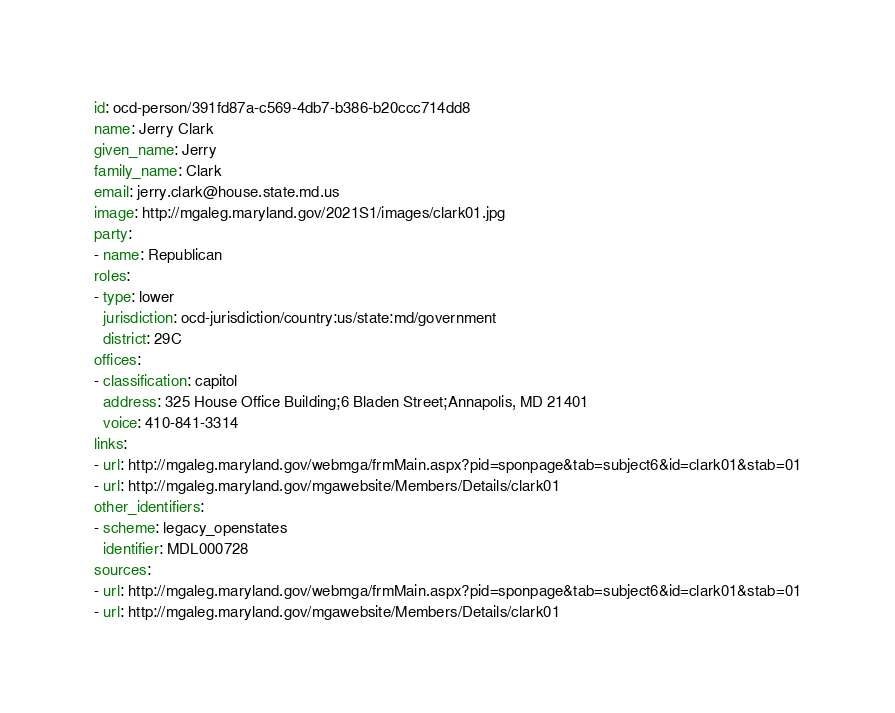<code> <loc_0><loc_0><loc_500><loc_500><_YAML_>id: ocd-person/391fd87a-c569-4db7-b386-b20ccc714dd8
name: Jerry Clark
given_name: Jerry
family_name: Clark
email: jerry.clark@house.state.md.us
image: http://mgaleg.maryland.gov/2021S1/images/clark01.jpg
party:
- name: Republican
roles:
- type: lower
  jurisdiction: ocd-jurisdiction/country:us/state:md/government
  district: 29C
offices:
- classification: capitol
  address: 325 House Office Building;6 Bladen Street;Annapolis, MD 21401
  voice: 410-841-3314
links:
- url: http://mgaleg.maryland.gov/webmga/frmMain.aspx?pid=sponpage&tab=subject6&id=clark01&stab=01
- url: http://mgaleg.maryland.gov/mgawebsite/Members/Details/clark01
other_identifiers:
- scheme: legacy_openstates
  identifier: MDL000728
sources:
- url: http://mgaleg.maryland.gov/webmga/frmMain.aspx?pid=sponpage&tab=subject6&id=clark01&stab=01
- url: http://mgaleg.maryland.gov/mgawebsite/Members/Details/clark01
</code> 